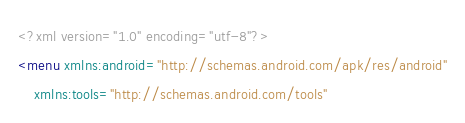Convert code to text. <code><loc_0><loc_0><loc_500><loc_500><_XML_><?xml version="1.0" encoding="utf-8"?>
<menu xmlns:android="http://schemas.android.com/apk/res/android"
    xmlns:tools="http://schemas.android.com/tools"</code> 